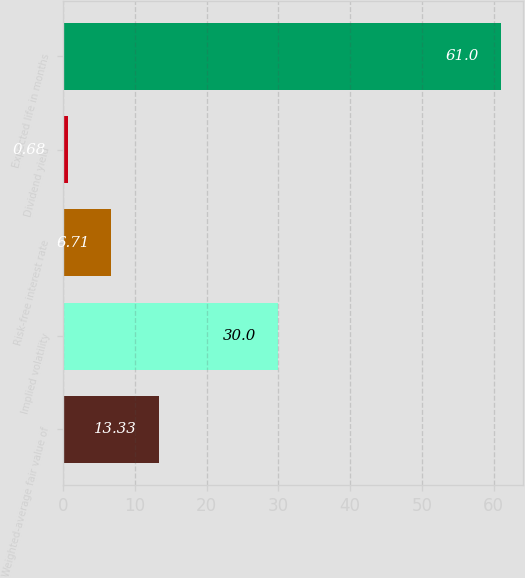<chart> <loc_0><loc_0><loc_500><loc_500><bar_chart><fcel>Weighted-average fair value of<fcel>Implied volatility<fcel>Risk-free interest rate<fcel>Dividend yield<fcel>Expected life in months<nl><fcel>13.33<fcel>30<fcel>6.71<fcel>0.68<fcel>61<nl></chart> 